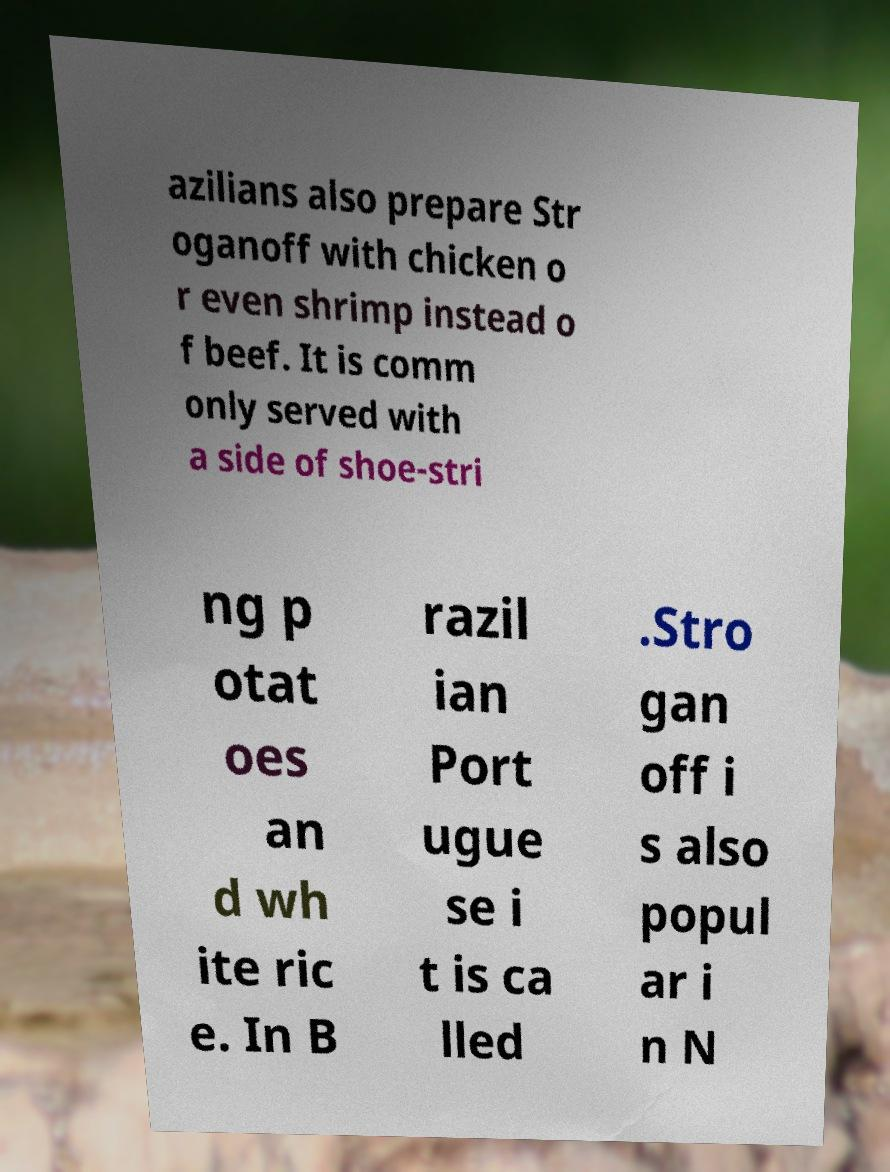Please read and relay the text visible in this image. What does it say? azilians also prepare Str oganoff with chicken o r even shrimp instead o f beef. It is comm only served with a side of shoe-stri ng p otat oes an d wh ite ric e. In B razil ian Port ugue se i t is ca lled .Stro gan off i s also popul ar i n N 